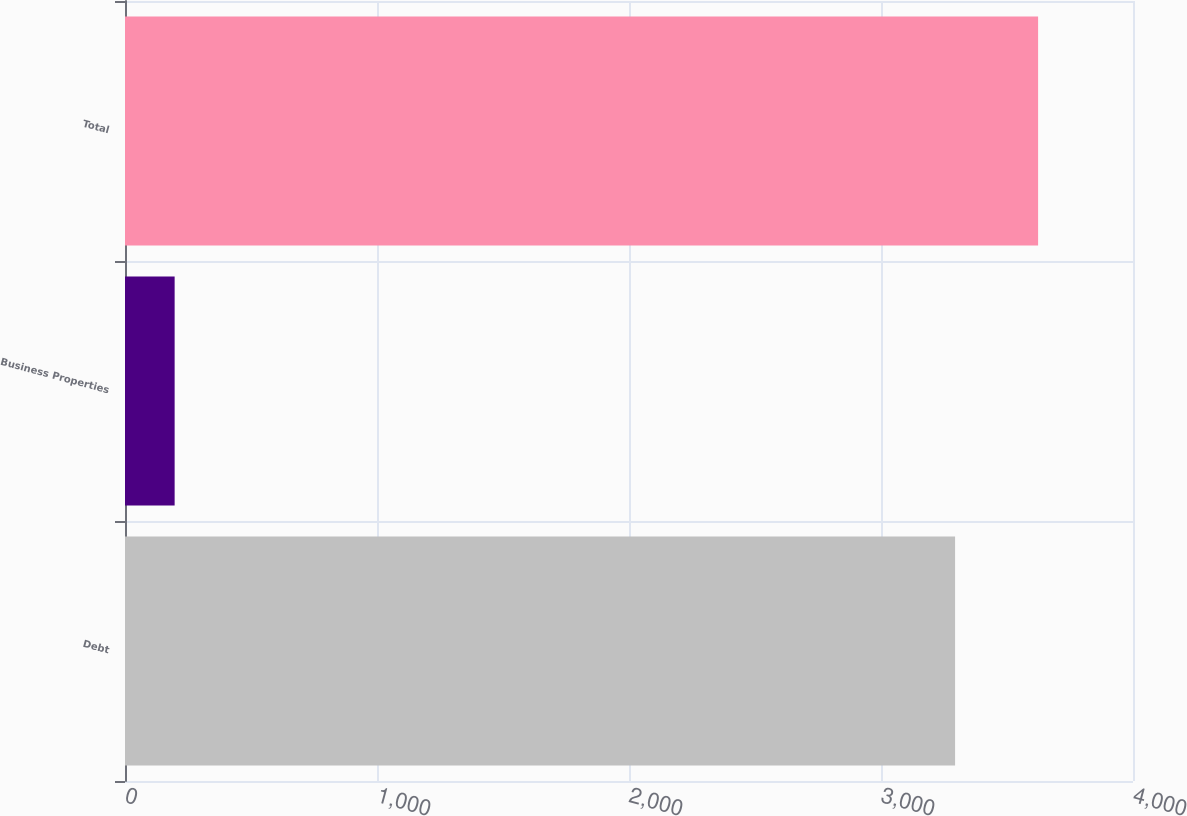Convert chart to OTSL. <chart><loc_0><loc_0><loc_500><loc_500><bar_chart><fcel>Debt<fcel>Business Properties<fcel>Total<nl><fcel>3294<fcel>197<fcel>3623.4<nl></chart> 